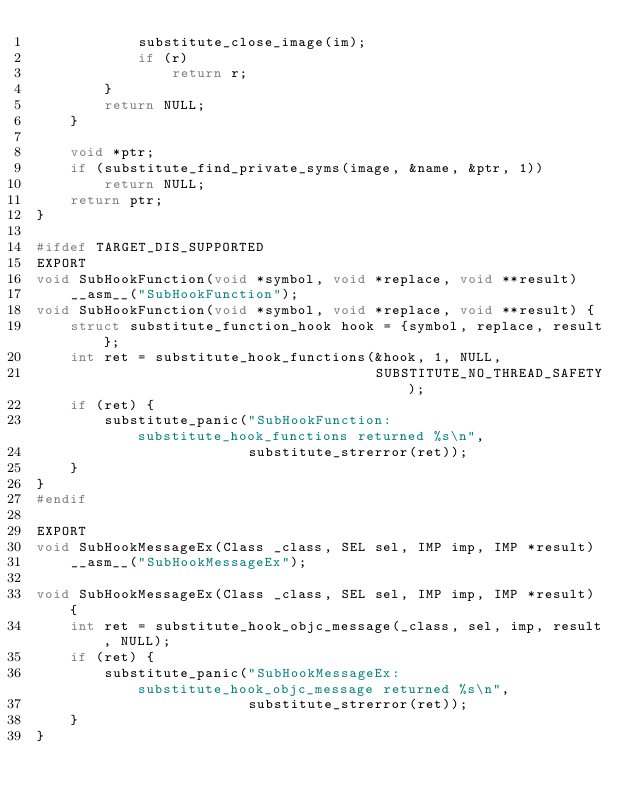<code> <loc_0><loc_0><loc_500><loc_500><_C_>            substitute_close_image(im);
            if (r)
                return r;
        }
        return NULL;
    }

    void *ptr;
    if (substitute_find_private_syms(image, &name, &ptr, 1))
        return NULL;
    return ptr;
}

#ifdef TARGET_DIS_SUPPORTED
EXPORT
void SubHookFunction(void *symbol, void *replace, void **result)
    __asm__("SubHookFunction");
void SubHookFunction(void *symbol, void *replace, void **result) {
    struct substitute_function_hook hook = {symbol, replace, result};
    int ret = substitute_hook_functions(&hook, 1, NULL,
                                        SUBSTITUTE_NO_THREAD_SAFETY);
    if (ret) {
        substitute_panic("SubHookFunction: substitute_hook_functions returned %s\n",
                         substitute_strerror(ret));
    }
}
#endif

EXPORT
void SubHookMessageEx(Class _class, SEL sel, IMP imp, IMP *result)
    __asm__("SubHookMessageEx");

void SubHookMessageEx(Class _class, SEL sel, IMP imp, IMP *result) {
    int ret = substitute_hook_objc_message(_class, sel, imp, result, NULL);
    if (ret) {
        substitute_panic("SubHookMessageEx: substitute_hook_objc_message returned %s\n",
                         substitute_strerror(ret));
    }
}
</code> 